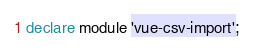Convert code to text. <code><loc_0><loc_0><loc_500><loc_500><_TypeScript_>declare module 'vue-csv-import';
</code> 